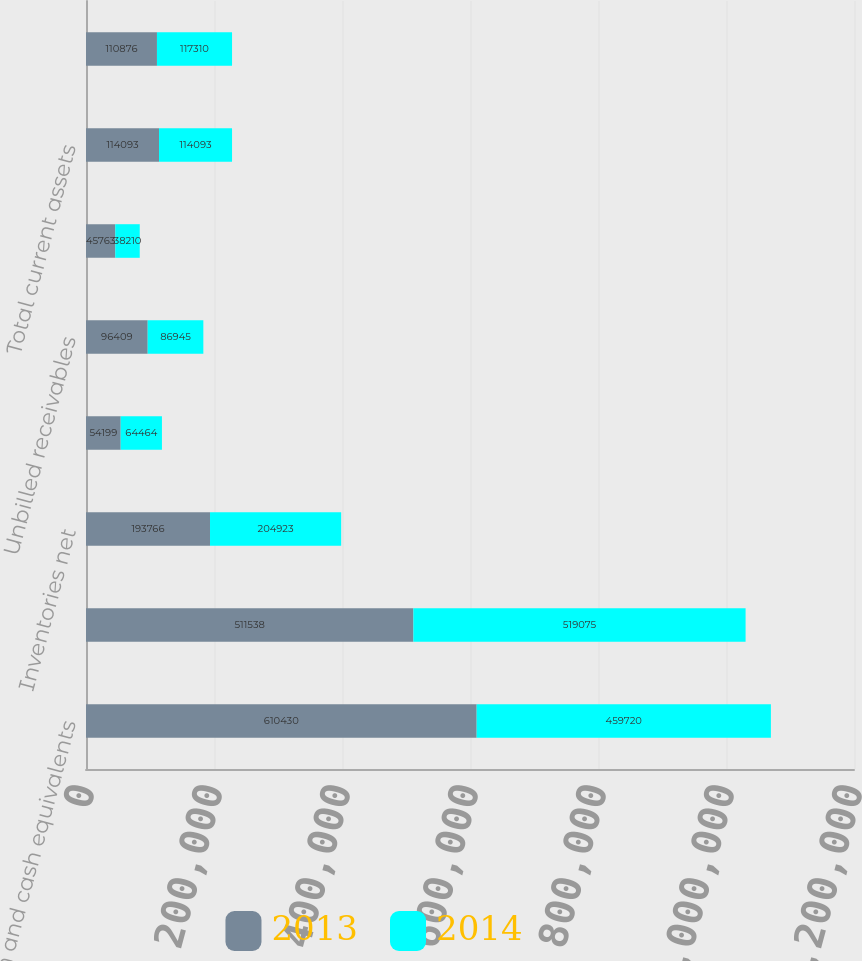Convert chart. <chart><loc_0><loc_0><loc_500><loc_500><stacked_bar_chart><ecel><fcel>Cash and cash equivalents<fcel>Accounts receivable net<fcel>Inventories net<fcel>Deferred taxes<fcel>Unbilled receivables<fcel>Other current assets<fcel>Total current assets<fcel>Property plant and equipment<nl><fcel>2013<fcel>610430<fcel>511538<fcel>193766<fcel>54199<fcel>96409<fcel>45763<fcel>114093<fcel>110876<nl><fcel>2014<fcel>459720<fcel>519075<fcel>204923<fcel>64464<fcel>86945<fcel>38210<fcel>114093<fcel>117310<nl></chart> 